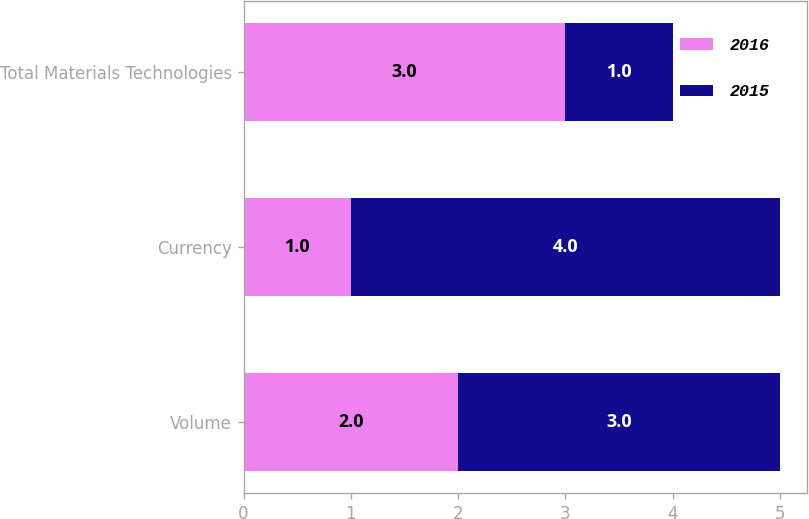Convert chart. <chart><loc_0><loc_0><loc_500><loc_500><stacked_bar_chart><ecel><fcel>Volume<fcel>Currency<fcel>Total Materials Technologies<nl><fcel>2016<fcel>2<fcel>1<fcel>3<nl><fcel>2015<fcel>3<fcel>4<fcel>1<nl></chart> 